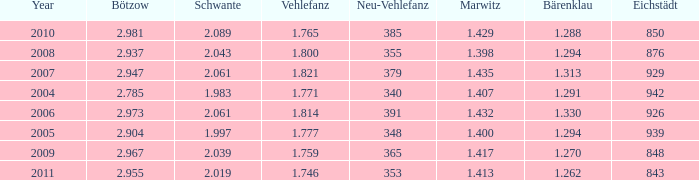Can you give me this table as a dict? {'header': ['Year', 'Bötzow', 'Schwante', 'Vehlefanz', 'Neu-Vehlefanz', 'Marwitz', 'Bärenklau', 'Eichstädt'], 'rows': [['2010', '2.981', '2.089', '1.765', '385', '1.429', '1.288', '850'], ['2008', '2.937', '2.043', '1.800', '355', '1.398', '1.294', '876'], ['2007', '2.947', '2.061', '1.821', '379', '1.435', '1.313', '929'], ['2004', '2.785', '1.983', '1.771', '340', '1.407', '1.291', '942'], ['2006', '2.973', '2.061', '1.814', '391', '1.432', '1.330', '926'], ['2005', '2.904', '1.997', '1.777', '348', '1.400', '1.294', '939'], ['2009', '2.967', '2.039', '1.759', '365', '1.417', '1.270', '848'], ['2011', '2.955', '2.019', '1.746', '353', '1.413', '1.262', '843']]} What year has a Schwante smaller than 2.043, an Eichstädt smaller than 848, and a Bärenklau smaller than 1.262? 0.0. 